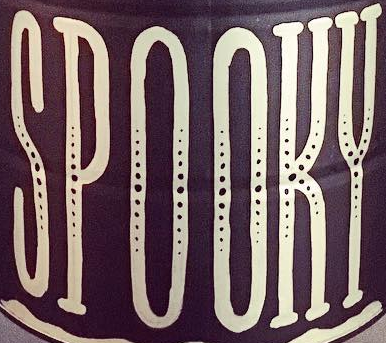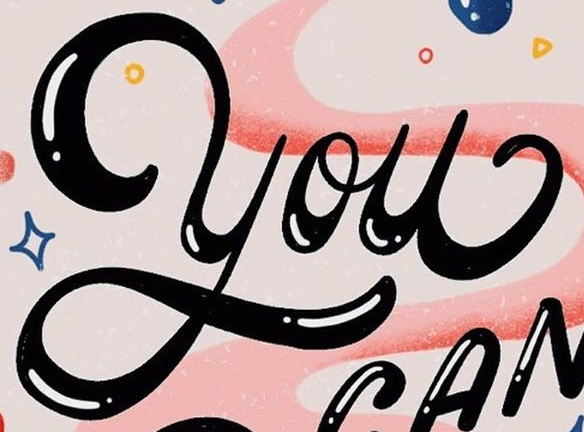Identify the words shown in these images in order, separated by a semicolon. SPOOKY; You 